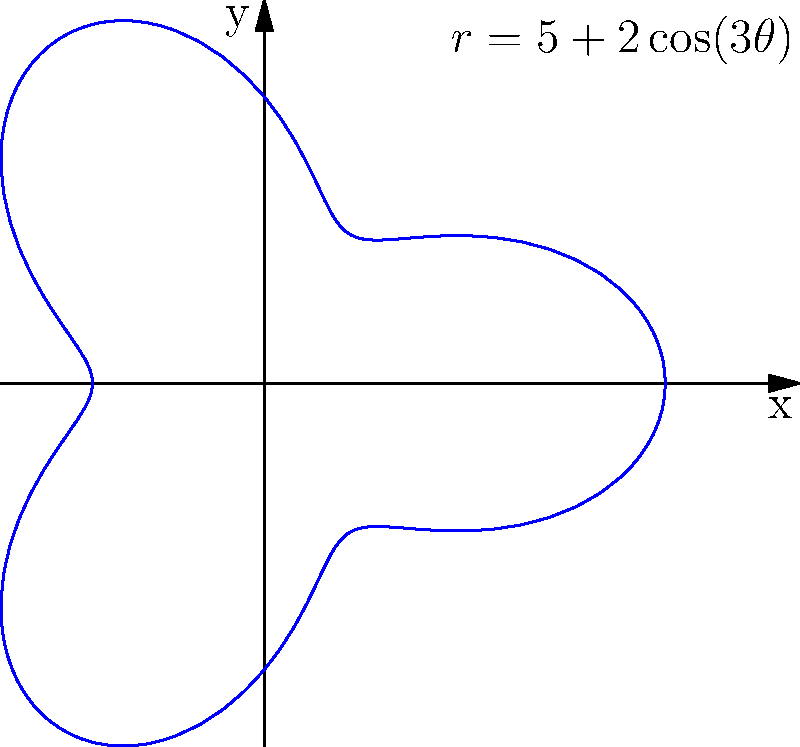As an environmental scientist, you are tasked with calculating the area of land suitable for a solar panel installation. The land area is represented by the polar curve $r=5+2\cos(3\theta)$ (in kilometers). Calculate the total area of this region in square kilometers. To calculate the area enclosed by a polar curve, we use the formula:

$$ A = \frac{1}{2} \int_{0}^{2\pi} r^2 d\theta $$

For our curve $r=5+2\cos(3\theta)$, we need to:

1. Square the radius function:
   $r^2 = (5+2\cos(3\theta))^2 = 25 + 20\cos(3\theta) + 4\cos^2(3\theta)$

2. Integrate this function from 0 to $2\pi$:
   $$ A = \frac{1}{2} \int_{0}^{2\pi} (25 + 20\cos(3\theta) + 4\cos^2(3\theta)) d\theta $$

3. Integrate each term:
   - $\int_{0}^{2\pi} 25 d\theta = 25\theta \big|_{0}^{2\pi} = 50\pi$
   - $\int_{0}^{2\pi} 20\cos(3\theta) d\theta = \frac{20}{3}\sin(3\theta) \big|_{0}^{2\pi} = 0$
   - $\int_{0}^{2\pi} 4\cos^2(3\theta) d\theta = 2\theta + \frac{2}{3}\sin(6\theta) \big|_{0}^{2\pi} = 4\pi$

4. Sum the results and multiply by $\frac{1}{2}$:
   $$ A = \frac{1}{2} (50\pi + 0 + 4\pi) = 27\pi $$

Therefore, the total area suitable for solar panel installation is $27\pi$ square kilometers.
Answer: $27\pi$ sq km 